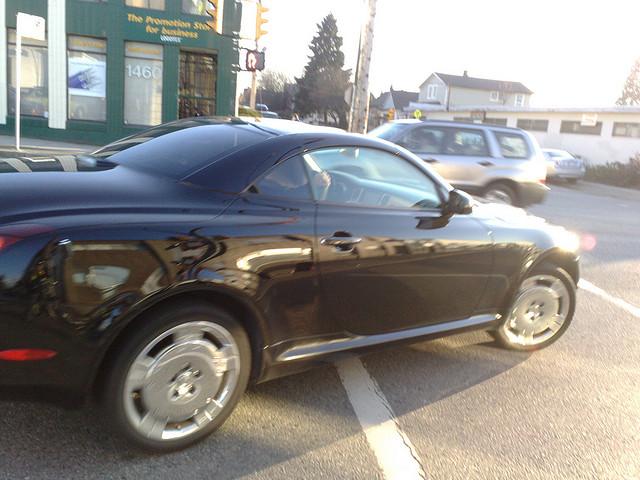Is this a good car for a family?
Write a very short answer. No. Is this a luxury car?
Give a very brief answer. Yes. What color is this car?
Write a very short answer. Black. Does this car have damage that's been fixed on it?
Write a very short answer. No. What is the color of the building behind the car?
Concise answer only. Green. How old is this car?
Short answer required. 5 years. 